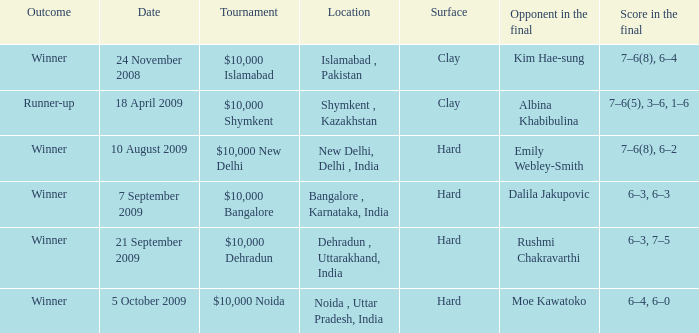In how many matches was the opponent in the final rushmi chakravarthi? 1.0. 